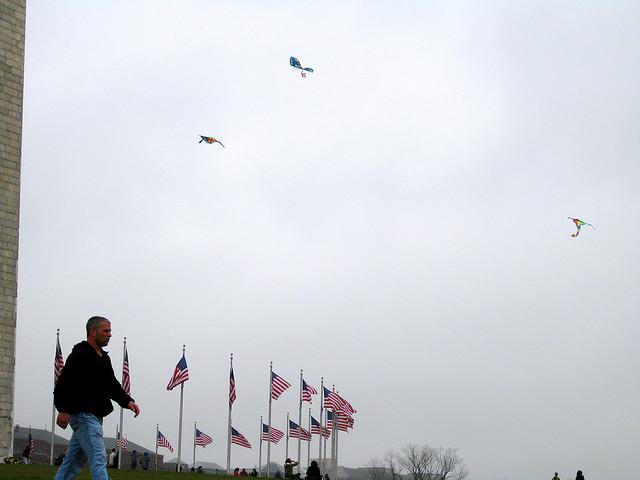Are there many people in the photo?
Be succinct. No. Is the man holding a bag of bread?
Give a very brief answer. No. What kind of kites are these?
Quick response, please. Flying. How many flags are there?
Concise answer only. 16. Is the man heavyset?
Give a very brief answer. No. Is this in America?
Short answer required. Yes. Does it appear to be raining?
Concise answer only. No. Which is the older item?
Keep it brief. Flag. How many flags are in the picture?
Give a very brief answer. 18. Is the man doing a trick?
Keep it brief. No. How many copies of the same guy are in the picture?
Write a very short answer. 1. Where is this located?
Give a very brief answer. United states. What color is the sky?
Answer briefly. Gray. How many stars on the flag are hidden?
Concise answer only. Several. What is in the air?
Write a very short answer. Kites. Are the birds looking at the water?
Quick response, please. No. How many flags are in the scene?
Concise answer only. 16. What is the man standing behind?
Write a very short answer. Flags. Is the man near a tree?
Write a very short answer. No. How many people are visible?
Give a very brief answer. 1. Where is the person?
Write a very short answer. Outside. What state flag is in the scene?
Concise answer only. United states. What is in the sky?
Keep it brief. Kites. Where is the person standing?
Write a very short answer. Outside. How many street lights are on the right?
Short answer required. 0. What flag is this?
Concise answer only. American. 